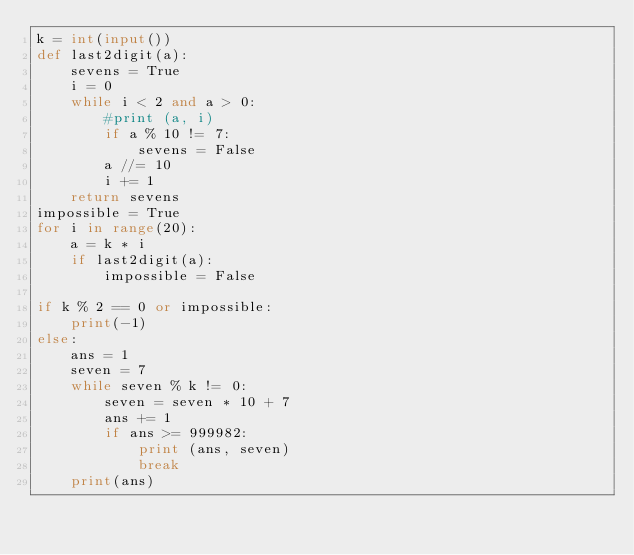<code> <loc_0><loc_0><loc_500><loc_500><_Python_>k = int(input())
def last2digit(a):
    sevens = True
    i = 0
    while i < 2 and a > 0:
        #print (a, i)
        if a % 10 != 7:
            sevens = False
        a //= 10
        i += 1
    return sevens
impossible = True
for i in range(20):
    a = k * i
    if last2digit(a):
        impossible = False

if k % 2 == 0 or impossible:
    print(-1)
else:
    ans = 1
    seven = 7
    while seven % k != 0:
        seven = seven * 10 + 7
        ans += 1
        if ans >= 999982:
            print (ans, seven)
            break
    print(ans)</code> 